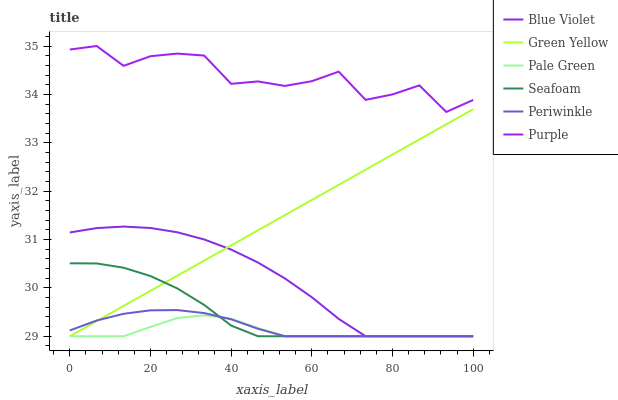Does Pale Green have the minimum area under the curve?
Answer yes or no. Yes. Does Purple have the maximum area under the curve?
Answer yes or no. Yes. Does Seafoam have the minimum area under the curve?
Answer yes or no. No. Does Seafoam have the maximum area under the curve?
Answer yes or no. No. Is Green Yellow the smoothest?
Answer yes or no. Yes. Is Purple the roughest?
Answer yes or no. Yes. Is Seafoam the smoothest?
Answer yes or no. No. Is Seafoam the roughest?
Answer yes or no. No. Does Purple have the highest value?
Answer yes or no. Yes. Does Seafoam have the highest value?
Answer yes or no. No. Is Blue Violet less than Purple?
Answer yes or no. Yes. Is Purple greater than Periwinkle?
Answer yes or no. Yes. Does Green Yellow intersect Blue Violet?
Answer yes or no. Yes. Is Green Yellow less than Blue Violet?
Answer yes or no. No. Is Green Yellow greater than Blue Violet?
Answer yes or no. No. Does Blue Violet intersect Purple?
Answer yes or no. No. 